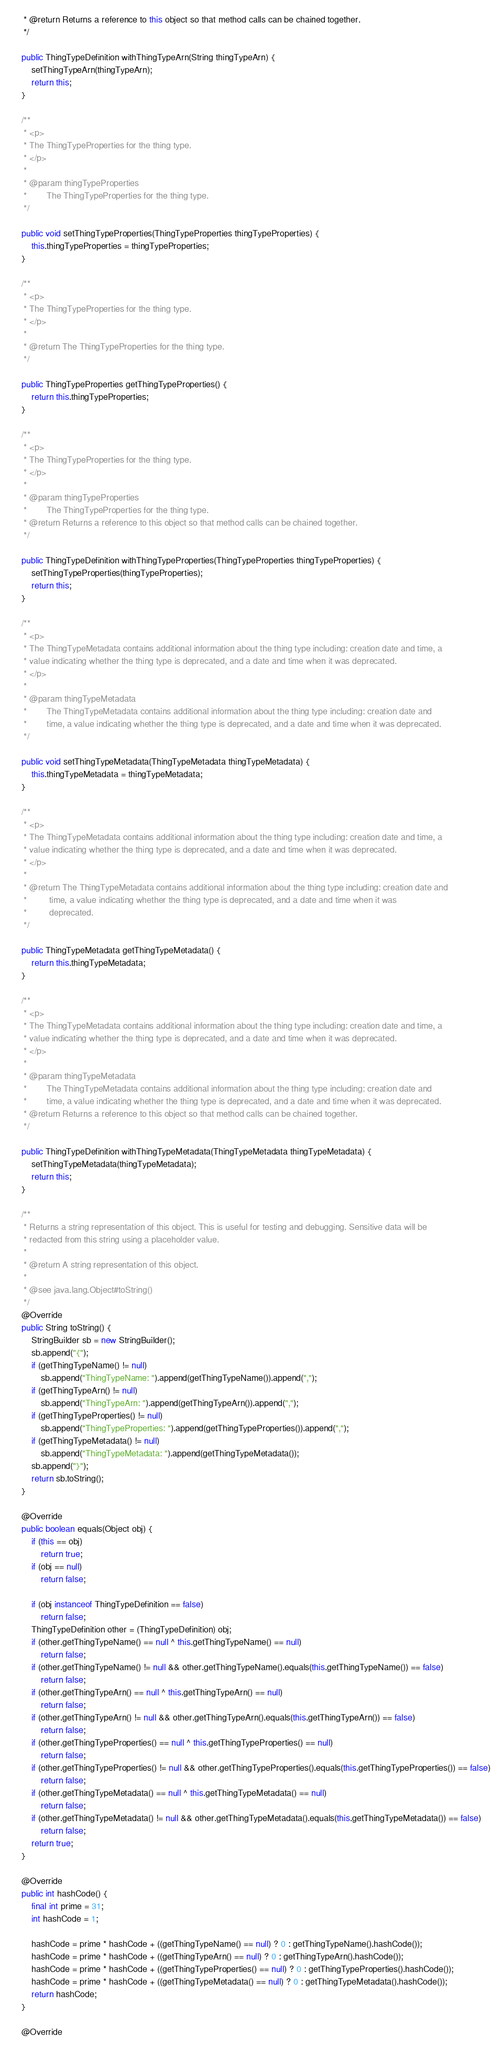Convert code to text. <code><loc_0><loc_0><loc_500><loc_500><_Java_>     * @return Returns a reference to this object so that method calls can be chained together.
     */

    public ThingTypeDefinition withThingTypeArn(String thingTypeArn) {
        setThingTypeArn(thingTypeArn);
        return this;
    }

    /**
     * <p>
     * The ThingTypeProperties for the thing type.
     * </p>
     * 
     * @param thingTypeProperties
     *        The ThingTypeProperties for the thing type.
     */

    public void setThingTypeProperties(ThingTypeProperties thingTypeProperties) {
        this.thingTypeProperties = thingTypeProperties;
    }

    /**
     * <p>
     * The ThingTypeProperties for the thing type.
     * </p>
     * 
     * @return The ThingTypeProperties for the thing type.
     */

    public ThingTypeProperties getThingTypeProperties() {
        return this.thingTypeProperties;
    }

    /**
     * <p>
     * The ThingTypeProperties for the thing type.
     * </p>
     * 
     * @param thingTypeProperties
     *        The ThingTypeProperties for the thing type.
     * @return Returns a reference to this object so that method calls can be chained together.
     */

    public ThingTypeDefinition withThingTypeProperties(ThingTypeProperties thingTypeProperties) {
        setThingTypeProperties(thingTypeProperties);
        return this;
    }

    /**
     * <p>
     * The ThingTypeMetadata contains additional information about the thing type including: creation date and time, a
     * value indicating whether the thing type is deprecated, and a date and time when it was deprecated.
     * </p>
     * 
     * @param thingTypeMetadata
     *        The ThingTypeMetadata contains additional information about the thing type including: creation date and
     *        time, a value indicating whether the thing type is deprecated, and a date and time when it was deprecated.
     */

    public void setThingTypeMetadata(ThingTypeMetadata thingTypeMetadata) {
        this.thingTypeMetadata = thingTypeMetadata;
    }

    /**
     * <p>
     * The ThingTypeMetadata contains additional information about the thing type including: creation date and time, a
     * value indicating whether the thing type is deprecated, and a date and time when it was deprecated.
     * </p>
     * 
     * @return The ThingTypeMetadata contains additional information about the thing type including: creation date and
     *         time, a value indicating whether the thing type is deprecated, and a date and time when it was
     *         deprecated.
     */

    public ThingTypeMetadata getThingTypeMetadata() {
        return this.thingTypeMetadata;
    }

    /**
     * <p>
     * The ThingTypeMetadata contains additional information about the thing type including: creation date and time, a
     * value indicating whether the thing type is deprecated, and a date and time when it was deprecated.
     * </p>
     * 
     * @param thingTypeMetadata
     *        The ThingTypeMetadata contains additional information about the thing type including: creation date and
     *        time, a value indicating whether the thing type is deprecated, and a date and time when it was deprecated.
     * @return Returns a reference to this object so that method calls can be chained together.
     */

    public ThingTypeDefinition withThingTypeMetadata(ThingTypeMetadata thingTypeMetadata) {
        setThingTypeMetadata(thingTypeMetadata);
        return this;
    }

    /**
     * Returns a string representation of this object. This is useful for testing and debugging. Sensitive data will be
     * redacted from this string using a placeholder value.
     *
     * @return A string representation of this object.
     *
     * @see java.lang.Object#toString()
     */
    @Override
    public String toString() {
        StringBuilder sb = new StringBuilder();
        sb.append("{");
        if (getThingTypeName() != null)
            sb.append("ThingTypeName: ").append(getThingTypeName()).append(",");
        if (getThingTypeArn() != null)
            sb.append("ThingTypeArn: ").append(getThingTypeArn()).append(",");
        if (getThingTypeProperties() != null)
            sb.append("ThingTypeProperties: ").append(getThingTypeProperties()).append(",");
        if (getThingTypeMetadata() != null)
            sb.append("ThingTypeMetadata: ").append(getThingTypeMetadata());
        sb.append("}");
        return sb.toString();
    }

    @Override
    public boolean equals(Object obj) {
        if (this == obj)
            return true;
        if (obj == null)
            return false;

        if (obj instanceof ThingTypeDefinition == false)
            return false;
        ThingTypeDefinition other = (ThingTypeDefinition) obj;
        if (other.getThingTypeName() == null ^ this.getThingTypeName() == null)
            return false;
        if (other.getThingTypeName() != null && other.getThingTypeName().equals(this.getThingTypeName()) == false)
            return false;
        if (other.getThingTypeArn() == null ^ this.getThingTypeArn() == null)
            return false;
        if (other.getThingTypeArn() != null && other.getThingTypeArn().equals(this.getThingTypeArn()) == false)
            return false;
        if (other.getThingTypeProperties() == null ^ this.getThingTypeProperties() == null)
            return false;
        if (other.getThingTypeProperties() != null && other.getThingTypeProperties().equals(this.getThingTypeProperties()) == false)
            return false;
        if (other.getThingTypeMetadata() == null ^ this.getThingTypeMetadata() == null)
            return false;
        if (other.getThingTypeMetadata() != null && other.getThingTypeMetadata().equals(this.getThingTypeMetadata()) == false)
            return false;
        return true;
    }

    @Override
    public int hashCode() {
        final int prime = 31;
        int hashCode = 1;

        hashCode = prime * hashCode + ((getThingTypeName() == null) ? 0 : getThingTypeName().hashCode());
        hashCode = prime * hashCode + ((getThingTypeArn() == null) ? 0 : getThingTypeArn().hashCode());
        hashCode = prime * hashCode + ((getThingTypeProperties() == null) ? 0 : getThingTypeProperties().hashCode());
        hashCode = prime * hashCode + ((getThingTypeMetadata() == null) ? 0 : getThingTypeMetadata().hashCode());
        return hashCode;
    }

    @Override</code> 